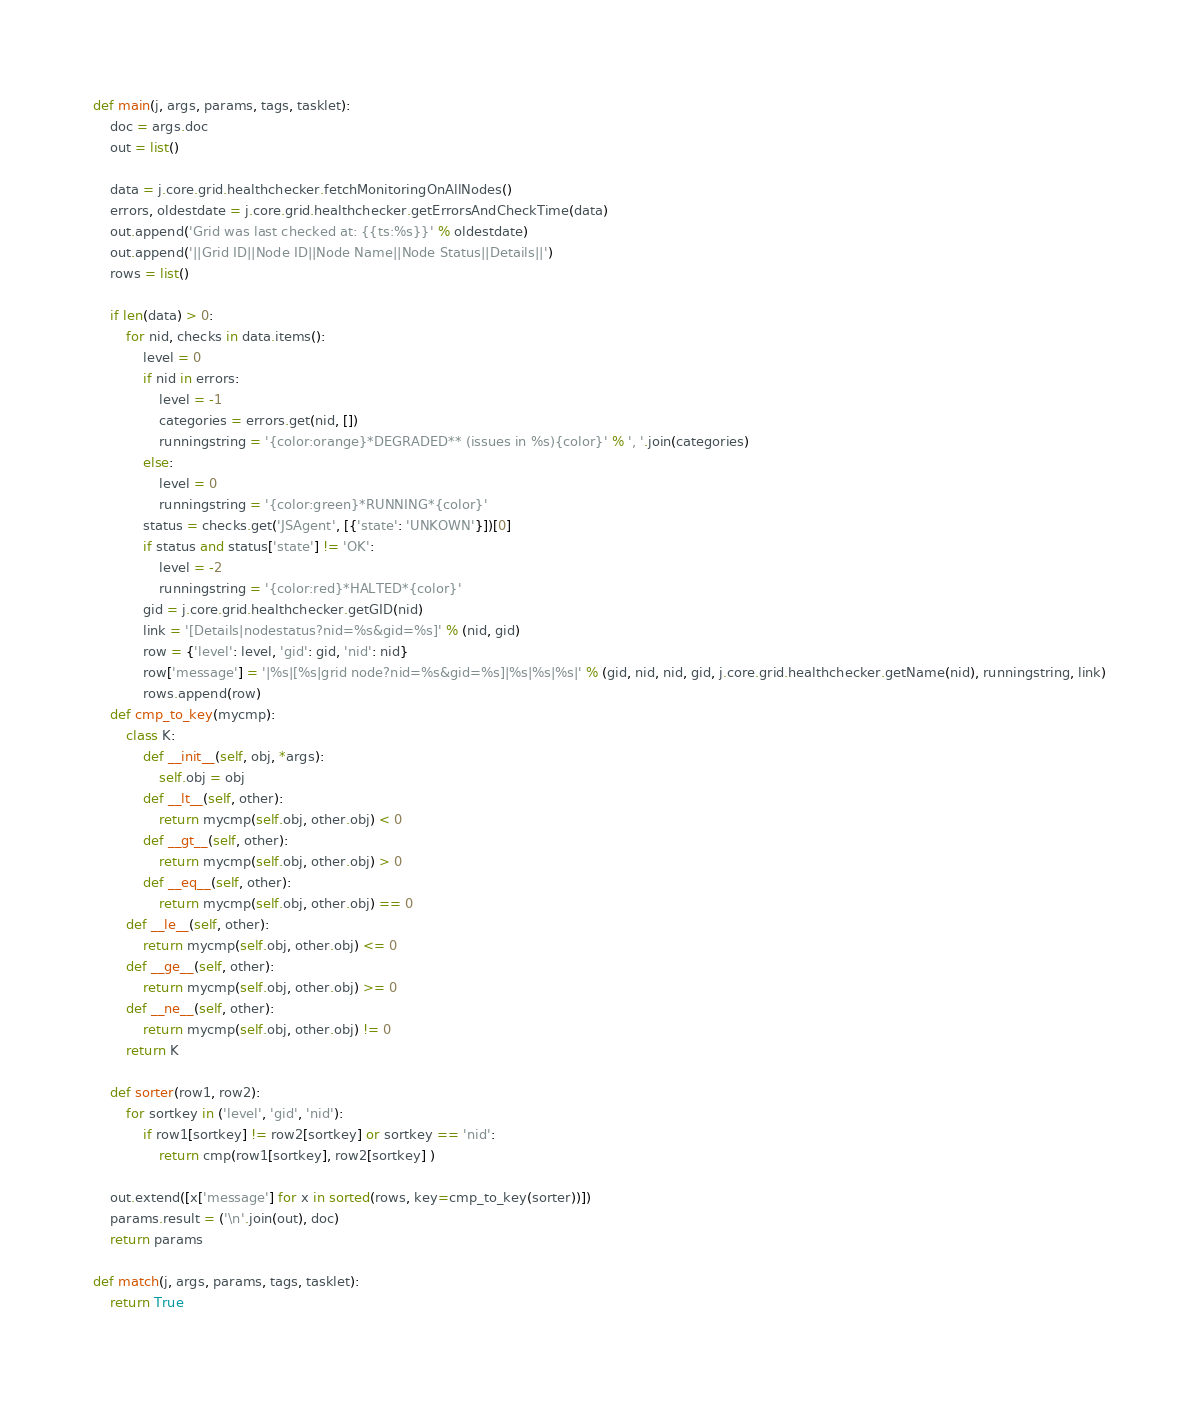<code> <loc_0><loc_0><loc_500><loc_500><_Python_>def main(j, args, params, tags, tasklet):
    doc = args.doc
    out = list()

    data = j.core.grid.healthchecker.fetchMonitoringOnAllNodes()
    errors, oldestdate = j.core.grid.healthchecker.getErrorsAndCheckTime(data)
    out.append('Grid was last checked at: {{ts:%s}}' % oldestdate)
    out.append('||Grid ID||Node ID||Node Name||Node Status||Details||')
    rows = list()

    if len(data) > 0:
        for nid, checks in data.items():
            level = 0
            if nid in errors:
                level = -1
                categories = errors.get(nid, [])
                runningstring = '{color:orange}*DEGRADED** (issues in %s){color}' % ', '.join(categories)
            else:
                level = 0
                runningstring = '{color:green}*RUNNING*{color}'
            status = checks.get('JSAgent', [{'state': 'UNKOWN'}])[0]
            if status and status['state'] != 'OK':
                level = -2
                runningstring = '{color:red}*HALTED*{color}'
            gid = j.core.grid.healthchecker.getGID(nid)
            link = '[Details|nodestatus?nid=%s&gid=%s]' % (nid, gid) 
            row = {'level': level, 'gid': gid, 'nid': nid}
            row['message'] = '|%s|[%s|grid node?nid=%s&gid=%s]|%s|%s|%s|' % (gid, nid, nid, gid, j.core.grid.healthchecker.getName(nid), runningstring, link)
            rows.append(row)
    def cmp_to_key(mycmp):
        class K:
            def __init__(self, obj, *args):
                self.obj = obj
            def __lt__(self, other):
                return mycmp(self.obj, other.obj) < 0
            def __gt__(self, other):
                return mycmp(self.obj, other.obj) > 0
            def __eq__(self, other):
                return mycmp(self.obj, other.obj) == 0
        def __le__(self, other):
            return mycmp(self.obj, other.obj) <= 0
        def __ge__(self, other):
            return mycmp(self.obj, other.obj) >= 0
        def __ne__(self, other):
            return mycmp(self.obj, other.obj) != 0
        return K

    def sorter(row1, row2):
        for sortkey in ('level', 'gid', 'nid'):
            if row1[sortkey] != row2[sortkey] or sortkey == 'nid':
                return cmp(row1[sortkey], row2[sortkey] )

    out.extend([x['message'] for x in sorted(rows, key=cmp_to_key(sorter))])
    params.result = ('\n'.join(out), doc)
    return params

def match(j, args, params, tags, tasklet):
    return True
</code> 